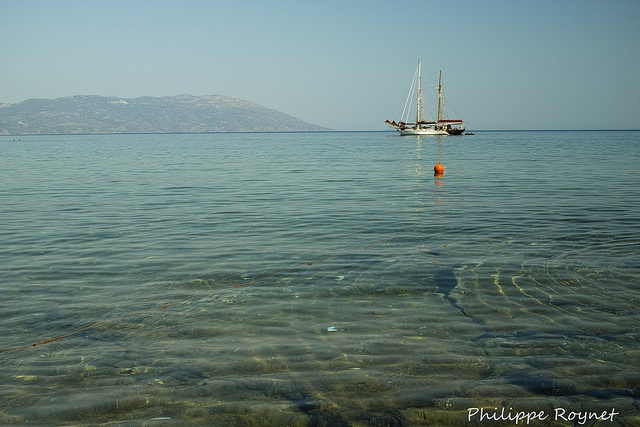Describe the objects in this image and their specific colors. I can see boat in lightblue, darkgray, gray, black, and beige tones and sports ball in lightblue, red, black, brown, and maroon tones in this image. 